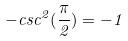<formula> <loc_0><loc_0><loc_500><loc_500>- c s c ^ { 2 } ( \frac { \pi } { 2 } ) = - 1</formula> 